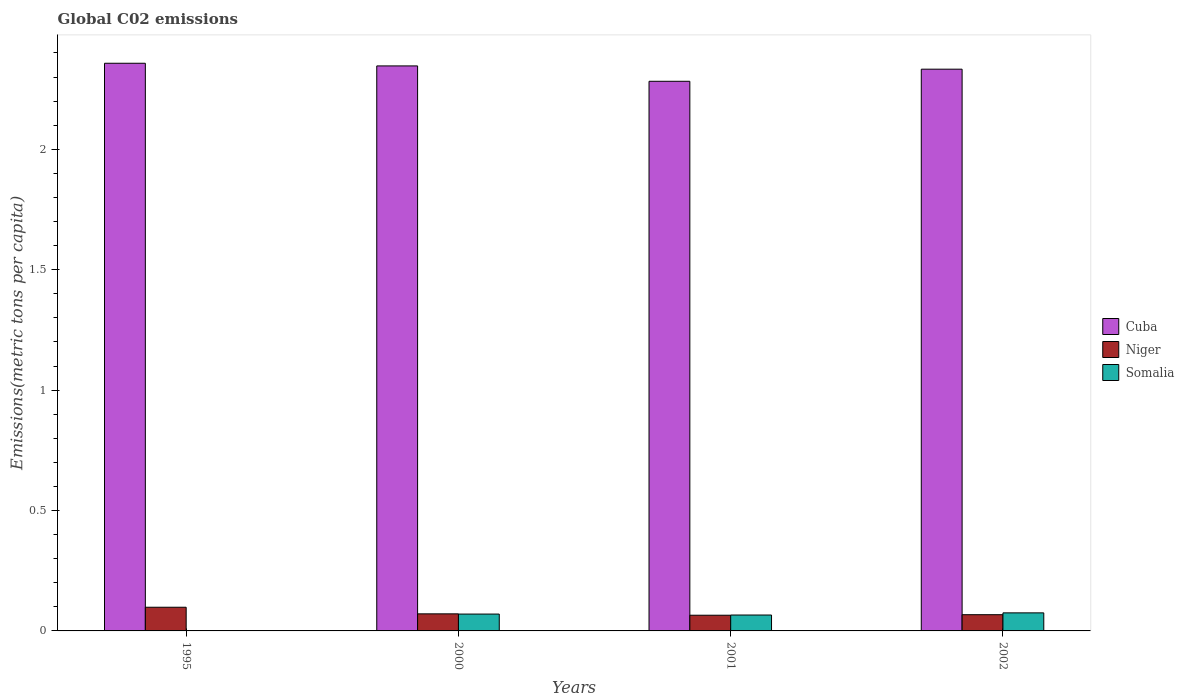How many groups of bars are there?
Make the answer very short. 4. Are the number of bars on each tick of the X-axis equal?
Make the answer very short. Yes. How many bars are there on the 3rd tick from the left?
Your answer should be compact. 3. How many bars are there on the 2nd tick from the right?
Your answer should be compact. 3. What is the amount of CO2 emitted in in Niger in 2002?
Make the answer very short. 0.07. Across all years, what is the maximum amount of CO2 emitted in in Niger?
Give a very brief answer. 0.1. Across all years, what is the minimum amount of CO2 emitted in in Cuba?
Provide a succinct answer. 2.28. In which year was the amount of CO2 emitted in in Cuba maximum?
Give a very brief answer. 1995. In which year was the amount of CO2 emitted in in Cuba minimum?
Make the answer very short. 2001. What is the total amount of CO2 emitted in in Cuba in the graph?
Offer a very short reply. 9.32. What is the difference between the amount of CO2 emitted in in Somalia in 2000 and that in 2001?
Offer a terse response. 0. What is the difference between the amount of CO2 emitted in in Cuba in 2001 and the amount of CO2 emitted in in Niger in 1995?
Provide a short and direct response. 2.18. What is the average amount of CO2 emitted in in Niger per year?
Give a very brief answer. 0.08. In the year 2002, what is the difference between the amount of CO2 emitted in in Cuba and amount of CO2 emitted in in Somalia?
Offer a very short reply. 2.26. What is the ratio of the amount of CO2 emitted in in Niger in 2001 to that in 2002?
Provide a short and direct response. 0.97. Is the difference between the amount of CO2 emitted in in Cuba in 2000 and 2002 greater than the difference between the amount of CO2 emitted in in Somalia in 2000 and 2002?
Make the answer very short. Yes. What is the difference between the highest and the second highest amount of CO2 emitted in in Niger?
Offer a terse response. 0.03. What is the difference between the highest and the lowest amount of CO2 emitted in in Niger?
Provide a short and direct response. 0.03. What does the 3rd bar from the left in 2001 represents?
Make the answer very short. Somalia. What does the 3rd bar from the right in 2000 represents?
Give a very brief answer. Cuba. Is it the case that in every year, the sum of the amount of CO2 emitted in in Cuba and amount of CO2 emitted in in Niger is greater than the amount of CO2 emitted in in Somalia?
Your answer should be compact. Yes. How many bars are there?
Offer a terse response. 12. How many years are there in the graph?
Give a very brief answer. 4. What is the difference between two consecutive major ticks on the Y-axis?
Provide a short and direct response. 0.5. Does the graph contain any zero values?
Provide a succinct answer. No. Does the graph contain grids?
Give a very brief answer. No. How many legend labels are there?
Your answer should be compact. 3. What is the title of the graph?
Offer a very short reply. Global C02 emissions. Does "Oman" appear as one of the legend labels in the graph?
Your response must be concise. No. What is the label or title of the X-axis?
Provide a short and direct response. Years. What is the label or title of the Y-axis?
Offer a very short reply. Emissions(metric tons per capita). What is the Emissions(metric tons per capita) of Cuba in 1995?
Provide a short and direct response. 2.36. What is the Emissions(metric tons per capita) in Niger in 1995?
Keep it short and to the point. 0.1. What is the Emissions(metric tons per capita) in Somalia in 1995?
Offer a terse response. 0. What is the Emissions(metric tons per capita) in Cuba in 2000?
Your response must be concise. 2.35. What is the Emissions(metric tons per capita) of Niger in 2000?
Ensure brevity in your answer.  0.07. What is the Emissions(metric tons per capita) in Somalia in 2000?
Keep it short and to the point. 0.07. What is the Emissions(metric tons per capita) of Cuba in 2001?
Make the answer very short. 2.28. What is the Emissions(metric tons per capita) in Niger in 2001?
Provide a succinct answer. 0.07. What is the Emissions(metric tons per capita) of Somalia in 2001?
Your answer should be compact. 0.07. What is the Emissions(metric tons per capita) of Cuba in 2002?
Provide a short and direct response. 2.33. What is the Emissions(metric tons per capita) of Niger in 2002?
Your response must be concise. 0.07. What is the Emissions(metric tons per capita) in Somalia in 2002?
Your response must be concise. 0.07. Across all years, what is the maximum Emissions(metric tons per capita) in Cuba?
Your answer should be compact. 2.36. Across all years, what is the maximum Emissions(metric tons per capita) of Niger?
Provide a succinct answer. 0.1. Across all years, what is the maximum Emissions(metric tons per capita) of Somalia?
Your answer should be compact. 0.07. Across all years, what is the minimum Emissions(metric tons per capita) of Cuba?
Your answer should be very brief. 2.28. Across all years, what is the minimum Emissions(metric tons per capita) in Niger?
Offer a very short reply. 0.07. Across all years, what is the minimum Emissions(metric tons per capita) in Somalia?
Give a very brief answer. 0. What is the total Emissions(metric tons per capita) in Cuba in the graph?
Ensure brevity in your answer.  9.32. What is the total Emissions(metric tons per capita) in Niger in the graph?
Provide a succinct answer. 0.3. What is the total Emissions(metric tons per capita) in Somalia in the graph?
Offer a terse response. 0.21. What is the difference between the Emissions(metric tons per capita) of Cuba in 1995 and that in 2000?
Your response must be concise. 0.01. What is the difference between the Emissions(metric tons per capita) of Niger in 1995 and that in 2000?
Your answer should be compact. 0.03. What is the difference between the Emissions(metric tons per capita) of Somalia in 1995 and that in 2000?
Keep it short and to the point. -0.07. What is the difference between the Emissions(metric tons per capita) in Cuba in 1995 and that in 2001?
Provide a succinct answer. 0.07. What is the difference between the Emissions(metric tons per capita) in Niger in 1995 and that in 2001?
Your response must be concise. 0.03. What is the difference between the Emissions(metric tons per capita) in Somalia in 1995 and that in 2001?
Give a very brief answer. -0.06. What is the difference between the Emissions(metric tons per capita) of Cuba in 1995 and that in 2002?
Provide a succinct answer. 0.02. What is the difference between the Emissions(metric tons per capita) of Niger in 1995 and that in 2002?
Your answer should be very brief. 0.03. What is the difference between the Emissions(metric tons per capita) in Somalia in 1995 and that in 2002?
Ensure brevity in your answer.  -0.07. What is the difference between the Emissions(metric tons per capita) in Cuba in 2000 and that in 2001?
Your answer should be very brief. 0.06. What is the difference between the Emissions(metric tons per capita) in Niger in 2000 and that in 2001?
Keep it short and to the point. 0.01. What is the difference between the Emissions(metric tons per capita) in Somalia in 2000 and that in 2001?
Provide a succinct answer. 0. What is the difference between the Emissions(metric tons per capita) of Cuba in 2000 and that in 2002?
Offer a terse response. 0.01. What is the difference between the Emissions(metric tons per capita) in Niger in 2000 and that in 2002?
Your response must be concise. 0. What is the difference between the Emissions(metric tons per capita) of Somalia in 2000 and that in 2002?
Keep it short and to the point. -0. What is the difference between the Emissions(metric tons per capita) of Cuba in 2001 and that in 2002?
Offer a terse response. -0.05. What is the difference between the Emissions(metric tons per capita) in Niger in 2001 and that in 2002?
Keep it short and to the point. -0. What is the difference between the Emissions(metric tons per capita) of Somalia in 2001 and that in 2002?
Your response must be concise. -0.01. What is the difference between the Emissions(metric tons per capita) of Cuba in 1995 and the Emissions(metric tons per capita) of Niger in 2000?
Your answer should be very brief. 2.29. What is the difference between the Emissions(metric tons per capita) in Cuba in 1995 and the Emissions(metric tons per capita) in Somalia in 2000?
Your answer should be compact. 2.29. What is the difference between the Emissions(metric tons per capita) in Niger in 1995 and the Emissions(metric tons per capita) in Somalia in 2000?
Provide a short and direct response. 0.03. What is the difference between the Emissions(metric tons per capita) in Cuba in 1995 and the Emissions(metric tons per capita) in Niger in 2001?
Make the answer very short. 2.29. What is the difference between the Emissions(metric tons per capita) in Cuba in 1995 and the Emissions(metric tons per capita) in Somalia in 2001?
Your answer should be very brief. 2.29. What is the difference between the Emissions(metric tons per capita) of Niger in 1995 and the Emissions(metric tons per capita) of Somalia in 2001?
Offer a terse response. 0.03. What is the difference between the Emissions(metric tons per capita) of Cuba in 1995 and the Emissions(metric tons per capita) of Niger in 2002?
Make the answer very short. 2.29. What is the difference between the Emissions(metric tons per capita) in Cuba in 1995 and the Emissions(metric tons per capita) in Somalia in 2002?
Give a very brief answer. 2.28. What is the difference between the Emissions(metric tons per capita) of Niger in 1995 and the Emissions(metric tons per capita) of Somalia in 2002?
Provide a short and direct response. 0.02. What is the difference between the Emissions(metric tons per capita) of Cuba in 2000 and the Emissions(metric tons per capita) of Niger in 2001?
Give a very brief answer. 2.28. What is the difference between the Emissions(metric tons per capita) of Cuba in 2000 and the Emissions(metric tons per capita) of Somalia in 2001?
Offer a terse response. 2.28. What is the difference between the Emissions(metric tons per capita) in Niger in 2000 and the Emissions(metric tons per capita) in Somalia in 2001?
Give a very brief answer. 0. What is the difference between the Emissions(metric tons per capita) of Cuba in 2000 and the Emissions(metric tons per capita) of Niger in 2002?
Offer a terse response. 2.28. What is the difference between the Emissions(metric tons per capita) in Cuba in 2000 and the Emissions(metric tons per capita) in Somalia in 2002?
Provide a succinct answer. 2.27. What is the difference between the Emissions(metric tons per capita) of Niger in 2000 and the Emissions(metric tons per capita) of Somalia in 2002?
Give a very brief answer. -0. What is the difference between the Emissions(metric tons per capita) of Cuba in 2001 and the Emissions(metric tons per capita) of Niger in 2002?
Your answer should be compact. 2.21. What is the difference between the Emissions(metric tons per capita) of Cuba in 2001 and the Emissions(metric tons per capita) of Somalia in 2002?
Provide a short and direct response. 2.21. What is the difference between the Emissions(metric tons per capita) of Niger in 2001 and the Emissions(metric tons per capita) of Somalia in 2002?
Offer a very short reply. -0.01. What is the average Emissions(metric tons per capita) of Cuba per year?
Provide a succinct answer. 2.33. What is the average Emissions(metric tons per capita) of Niger per year?
Make the answer very short. 0.08. What is the average Emissions(metric tons per capita) of Somalia per year?
Your answer should be compact. 0.05. In the year 1995, what is the difference between the Emissions(metric tons per capita) of Cuba and Emissions(metric tons per capita) of Niger?
Make the answer very short. 2.26. In the year 1995, what is the difference between the Emissions(metric tons per capita) of Cuba and Emissions(metric tons per capita) of Somalia?
Your answer should be compact. 2.36. In the year 1995, what is the difference between the Emissions(metric tons per capita) in Niger and Emissions(metric tons per capita) in Somalia?
Make the answer very short. 0.1. In the year 2000, what is the difference between the Emissions(metric tons per capita) in Cuba and Emissions(metric tons per capita) in Niger?
Your answer should be compact. 2.28. In the year 2000, what is the difference between the Emissions(metric tons per capita) in Cuba and Emissions(metric tons per capita) in Somalia?
Your response must be concise. 2.28. In the year 2000, what is the difference between the Emissions(metric tons per capita) in Niger and Emissions(metric tons per capita) in Somalia?
Your response must be concise. 0. In the year 2001, what is the difference between the Emissions(metric tons per capita) of Cuba and Emissions(metric tons per capita) of Niger?
Keep it short and to the point. 2.22. In the year 2001, what is the difference between the Emissions(metric tons per capita) of Cuba and Emissions(metric tons per capita) of Somalia?
Your response must be concise. 2.22. In the year 2001, what is the difference between the Emissions(metric tons per capita) in Niger and Emissions(metric tons per capita) in Somalia?
Offer a very short reply. -0. In the year 2002, what is the difference between the Emissions(metric tons per capita) of Cuba and Emissions(metric tons per capita) of Niger?
Provide a short and direct response. 2.27. In the year 2002, what is the difference between the Emissions(metric tons per capita) in Cuba and Emissions(metric tons per capita) in Somalia?
Your response must be concise. 2.26. In the year 2002, what is the difference between the Emissions(metric tons per capita) in Niger and Emissions(metric tons per capita) in Somalia?
Give a very brief answer. -0.01. What is the ratio of the Emissions(metric tons per capita) of Cuba in 1995 to that in 2000?
Keep it short and to the point. 1. What is the ratio of the Emissions(metric tons per capita) of Niger in 1995 to that in 2000?
Your response must be concise. 1.39. What is the ratio of the Emissions(metric tons per capita) of Somalia in 1995 to that in 2000?
Keep it short and to the point. 0.02. What is the ratio of the Emissions(metric tons per capita) in Cuba in 1995 to that in 2001?
Keep it short and to the point. 1.03. What is the ratio of the Emissions(metric tons per capita) of Niger in 1995 to that in 2001?
Provide a succinct answer. 1.51. What is the ratio of the Emissions(metric tons per capita) in Somalia in 1995 to that in 2001?
Make the answer very short. 0.03. What is the ratio of the Emissions(metric tons per capita) in Cuba in 1995 to that in 2002?
Offer a very short reply. 1.01. What is the ratio of the Emissions(metric tons per capita) of Niger in 1995 to that in 2002?
Your answer should be compact. 1.46. What is the ratio of the Emissions(metric tons per capita) in Somalia in 1995 to that in 2002?
Offer a terse response. 0.02. What is the ratio of the Emissions(metric tons per capita) in Cuba in 2000 to that in 2001?
Offer a very short reply. 1.03. What is the ratio of the Emissions(metric tons per capita) of Niger in 2000 to that in 2001?
Make the answer very short. 1.09. What is the ratio of the Emissions(metric tons per capita) of Somalia in 2000 to that in 2001?
Give a very brief answer. 1.06. What is the ratio of the Emissions(metric tons per capita) in Cuba in 2000 to that in 2002?
Give a very brief answer. 1.01. What is the ratio of the Emissions(metric tons per capita) of Niger in 2000 to that in 2002?
Your response must be concise. 1.05. What is the ratio of the Emissions(metric tons per capita) in Somalia in 2000 to that in 2002?
Make the answer very short. 0.93. What is the ratio of the Emissions(metric tons per capita) of Cuba in 2001 to that in 2002?
Keep it short and to the point. 0.98. What is the ratio of the Emissions(metric tons per capita) of Niger in 2001 to that in 2002?
Keep it short and to the point. 0.97. What is the ratio of the Emissions(metric tons per capita) of Somalia in 2001 to that in 2002?
Make the answer very short. 0.88. What is the difference between the highest and the second highest Emissions(metric tons per capita) in Cuba?
Your answer should be very brief. 0.01. What is the difference between the highest and the second highest Emissions(metric tons per capita) in Niger?
Provide a succinct answer. 0.03. What is the difference between the highest and the second highest Emissions(metric tons per capita) of Somalia?
Offer a very short reply. 0. What is the difference between the highest and the lowest Emissions(metric tons per capita) of Cuba?
Provide a short and direct response. 0.07. What is the difference between the highest and the lowest Emissions(metric tons per capita) in Niger?
Offer a terse response. 0.03. What is the difference between the highest and the lowest Emissions(metric tons per capita) in Somalia?
Ensure brevity in your answer.  0.07. 